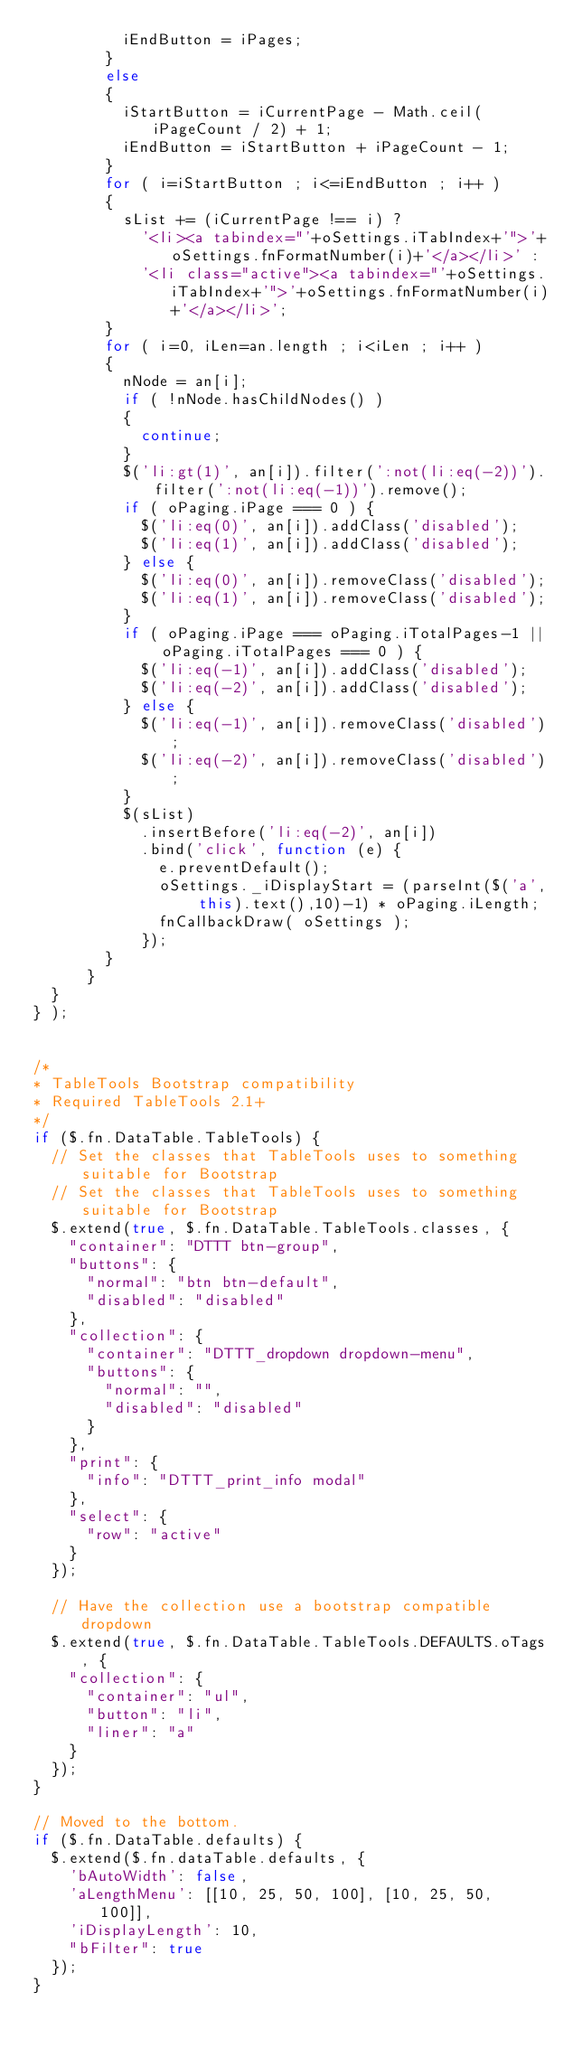<code> <loc_0><loc_0><loc_500><loc_500><_JavaScript_>					iEndButton = iPages;
				}
				else
				{
					iStartButton = iCurrentPage - Math.ceil(iPageCount / 2) + 1;
					iEndButton = iStartButton + iPageCount - 1;
				}
				for ( i=iStartButton ; i<=iEndButton ; i++ )
				{
					sList += (iCurrentPage !== i) ?
						'<li><a tabindex="'+oSettings.iTabIndex+'">'+oSettings.fnFormatNumber(i)+'</a></li>' :
						'<li class="active"><a tabindex="'+oSettings.iTabIndex+'">'+oSettings.fnFormatNumber(i)+'</a></li>';
				}
				for ( i=0, iLen=an.length ; i<iLen ; i++ )
				{
					nNode = an[i];
					if ( !nNode.hasChildNodes() )
					{
						continue;
					}
					$('li:gt(1)', an[i]).filter(':not(li:eq(-2))').filter(':not(li:eq(-1))').remove();
					if ( oPaging.iPage === 0 ) {
						$('li:eq(0)', an[i]).addClass('disabled');
						$('li:eq(1)', an[i]).addClass('disabled');
					} else {
						$('li:eq(0)', an[i]).removeClass('disabled');
						$('li:eq(1)', an[i]).removeClass('disabled');
					}
					if ( oPaging.iPage === oPaging.iTotalPages-1 || oPaging.iTotalPages === 0 ) {
						$('li:eq(-1)', an[i]).addClass('disabled');
						$('li:eq(-2)', an[i]).addClass('disabled');
					} else {
						$('li:eq(-1)', an[i]).removeClass('disabled');
						$('li:eq(-2)', an[i]).removeClass('disabled');
					}
					$(sList)
						.insertBefore('li:eq(-2)', an[i])
						.bind('click', function (e) {
							e.preventDefault();
							oSettings._iDisplayStart = (parseInt($('a', this).text(),10)-1) * oPaging.iLength;
							fnCallbackDraw( oSettings );
						});
				}
			}
	}	
} );
 
 
/*
* TableTools Bootstrap compatibility
* Required TableTools 2.1+
*/
if ($.fn.DataTable.TableTools) {
  // Set the classes that TableTools uses to something suitable for Bootstrap
  // Set the classes that TableTools uses to something suitable for Bootstrap
  $.extend(true, $.fn.DataTable.TableTools.classes, {
    "container": "DTTT btn-group",
    "buttons": {
      "normal": "btn btn-default",
      "disabled": "disabled"
    },
    "collection": {
      "container": "DTTT_dropdown dropdown-menu",
      "buttons": {
        "normal": "",
        "disabled": "disabled"
      }
    },
    "print": {
      "info": "DTTT_print_info modal"
    },
    "select": {
      "row": "active"
    }
  });
 
  // Have the collection use a bootstrap compatible dropdown
  $.extend(true, $.fn.DataTable.TableTools.DEFAULTS.oTags, {
    "collection": {
      "container": "ul",
      "button": "li",
      "liner": "a"
    }
  });
}
 
// Moved to the bottom.
if ($.fn.DataTable.defaults) {
  $.extend($.fn.dataTable.defaults, {
    'bAutoWidth': false,
    'aLengthMenu': [[10, 25, 50, 100], [10, 25, 50, 100]],
    'iDisplayLength': 10,
    "bFilter": true
  });
}</code> 